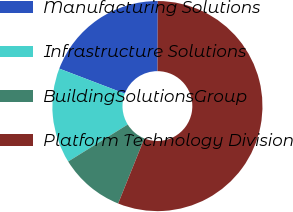Convert chart to OTSL. <chart><loc_0><loc_0><loc_500><loc_500><pie_chart><fcel>Manufacturing Solutions<fcel>Infrastructure Solutions<fcel>BuildingSolutionsGroup<fcel>Platform Technology Division<nl><fcel>19.25%<fcel>14.65%<fcel>10.06%<fcel>56.04%<nl></chart> 